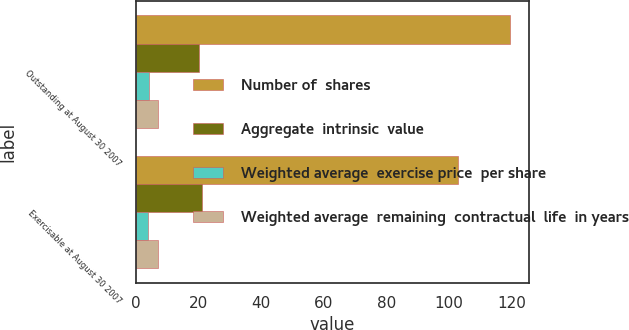<chart> <loc_0><loc_0><loc_500><loc_500><stacked_bar_chart><ecel><fcel>Outstanding at August 30 2007<fcel>Exercisable at August 30 2007<nl><fcel>Number of  shares<fcel>119.5<fcel>102.9<nl><fcel>Aggregate  intrinsic  value<fcel>20<fcel>21.12<nl><fcel>Weighted average  exercise price  per share<fcel>4.02<fcel>3.87<nl><fcel>Weighted average  remaining  contractual  life  in years<fcel>7<fcel>7<nl></chart> 